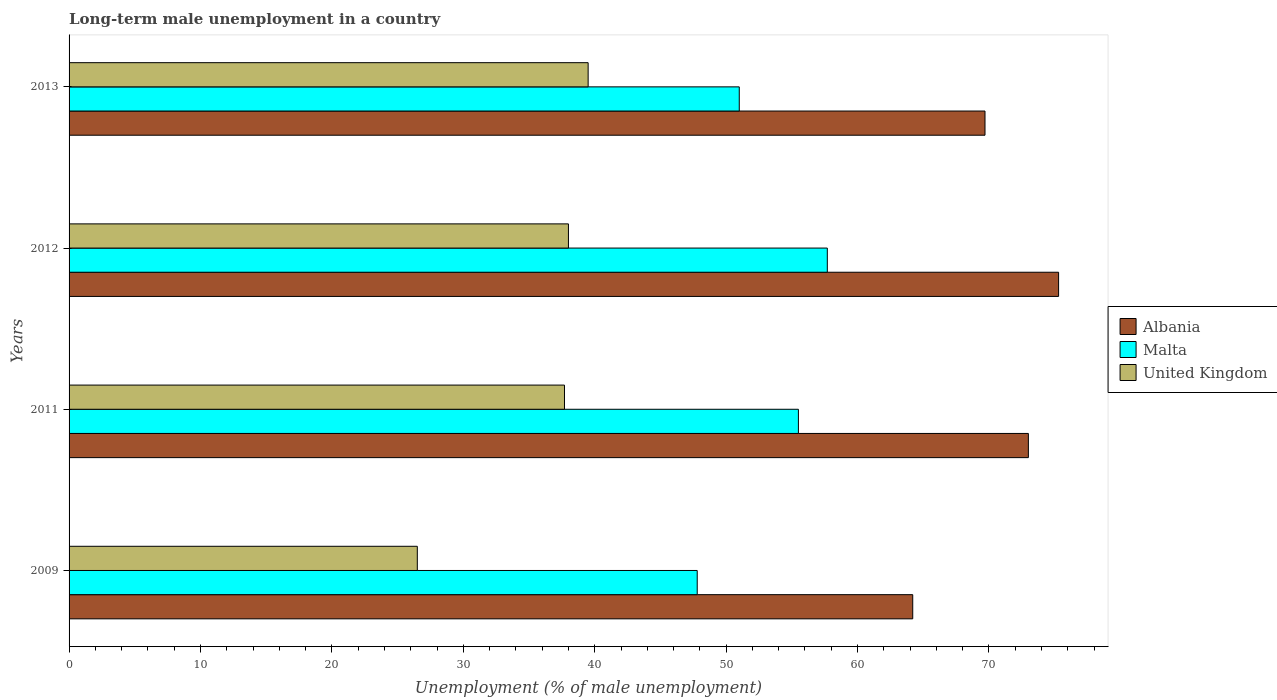How many different coloured bars are there?
Offer a terse response. 3. How many groups of bars are there?
Provide a succinct answer. 4. Are the number of bars per tick equal to the number of legend labels?
Your response must be concise. Yes. How many bars are there on the 4th tick from the top?
Offer a very short reply. 3. What is the label of the 2nd group of bars from the top?
Your answer should be compact. 2012. What is the percentage of long-term unemployed male population in Albania in 2009?
Keep it short and to the point. 64.2. Across all years, what is the maximum percentage of long-term unemployed male population in Albania?
Keep it short and to the point. 75.3. Across all years, what is the minimum percentage of long-term unemployed male population in Malta?
Your answer should be very brief. 47.8. In which year was the percentage of long-term unemployed male population in Malta maximum?
Offer a very short reply. 2012. What is the total percentage of long-term unemployed male population in Albania in the graph?
Your answer should be very brief. 282.2. What is the difference between the percentage of long-term unemployed male population in Malta in 2009 and that in 2013?
Your answer should be very brief. -3.2. What is the difference between the percentage of long-term unemployed male population in Albania in 2009 and the percentage of long-term unemployed male population in United Kingdom in 2013?
Make the answer very short. 24.7. What is the average percentage of long-term unemployed male population in Albania per year?
Make the answer very short. 70.55. In the year 2011, what is the difference between the percentage of long-term unemployed male population in Malta and percentage of long-term unemployed male population in United Kingdom?
Your response must be concise. 17.8. What is the ratio of the percentage of long-term unemployed male population in United Kingdom in 2011 to that in 2013?
Offer a terse response. 0.95. What is the difference between the highest and the second highest percentage of long-term unemployed male population in Albania?
Keep it short and to the point. 2.3. What is the difference between the highest and the lowest percentage of long-term unemployed male population in Malta?
Your response must be concise. 9.9. In how many years, is the percentage of long-term unemployed male population in Albania greater than the average percentage of long-term unemployed male population in Albania taken over all years?
Ensure brevity in your answer.  2. Is the sum of the percentage of long-term unemployed male population in Malta in 2009 and 2013 greater than the maximum percentage of long-term unemployed male population in Albania across all years?
Provide a short and direct response. Yes. What does the 2nd bar from the top in 2013 represents?
Make the answer very short. Malta. What does the 1st bar from the bottom in 2013 represents?
Offer a terse response. Albania. How many bars are there?
Provide a short and direct response. 12. Are all the bars in the graph horizontal?
Your answer should be compact. Yes. How many years are there in the graph?
Keep it short and to the point. 4. What is the difference between two consecutive major ticks on the X-axis?
Ensure brevity in your answer.  10. Does the graph contain grids?
Your response must be concise. No. How are the legend labels stacked?
Make the answer very short. Vertical. What is the title of the graph?
Your answer should be compact. Long-term male unemployment in a country. What is the label or title of the X-axis?
Give a very brief answer. Unemployment (% of male unemployment). What is the Unemployment (% of male unemployment) of Albania in 2009?
Make the answer very short. 64.2. What is the Unemployment (% of male unemployment) of Malta in 2009?
Ensure brevity in your answer.  47.8. What is the Unemployment (% of male unemployment) in Albania in 2011?
Your response must be concise. 73. What is the Unemployment (% of male unemployment) in Malta in 2011?
Offer a very short reply. 55.5. What is the Unemployment (% of male unemployment) in United Kingdom in 2011?
Your answer should be very brief. 37.7. What is the Unemployment (% of male unemployment) of Albania in 2012?
Offer a terse response. 75.3. What is the Unemployment (% of male unemployment) of Malta in 2012?
Keep it short and to the point. 57.7. What is the Unemployment (% of male unemployment) in United Kingdom in 2012?
Give a very brief answer. 38. What is the Unemployment (% of male unemployment) in Albania in 2013?
Provide a short and direct response. 69.7. What is the Unemployment (% of male unemployment) of Malta in 2013?
Make the answer very short. 51. What is the Unemployment (% of male unemployment) of United Kingdom in 2013?
Keep it short and to the point. 39.5. Across all years, what is the maximum Unemployment (% of male unemployment) in Albania?
Your answer should be compact. 75.3. Across all years, what is the maximum Unemployment (% of male unemployment) of Malta?
Offer a terse response. 57.7. Across all years, what is the maximum Unemployment (% of male unemployment) of United Kingdom?
Keep it short and to the point. 39.5. Across all years, what is the minimum Unemployment (% of male unemployment) of Albania?
Give a very brief answer. 64.2. Across all years, what is the minimum Unemployment (% of male unemployment) of Malta?
Make the answer very short. 47.8. Across all years, what is the minimum Unemployment (% of male unemployment) in United Kingdom?
Make the answer very short. 26.5. What is the total Unemployment (% of male unemployment) in Albania in the graph?
Your response must be concise. 282.2. What is the total Unemployment (% of male unemployment) in Malta in the graph?
Provide a short and direct response. 212. What is the total Unemployment (% of male unemployment) in United Kingdom in the graph?
Provide a succinct answer. 141.7. What is the difference between the Unemployment (% of male unemployment) in Albania in 2009 and that in 2011?
Provide a short and direct response. -8.8. What is the difference between the Unemployment (% of male unemployment) in Malta in 2009 and that in 2011?
Offer a very short reply. -7.7. What is the difference between the Unemployment (% of male unemployment) in Albania in 2009 and that in 2012?
Your answer should be compact. -11.1. What is the difference between the Unemployment (% of male unemployment) in Malta in 2009 and that in 2012?
Your response must be concise. -9.9. What is the difference between the Unemployment (% of male unemployment) in United Kingdom in 2009 and that in 2012?
Give a very brief answer. -11.5. What is the difference between the Unemployment (% of male unemployment) in Malta in 2009 and that in 2013?
Your answer should be very brief. -3.2. What is the difference between the Unemployment (% of male unemployment) in United Kingdom in 2009 and that in 2013?
Your response must be concise. -13. What is the difference between the Unemployment (% of male unemployment) of Albania in 2011 and that in 2012?
Provide a short and direct response. -2.3. What is the difference between the Unemployment (% of male unemployment) in Malta in 2011 and that in 2012?
Your answer should be very brief. -2.2. What is the difference between the Unemployment (% of male unemployment) of United Kingdom in 2011 and that in 2013?
Your answer should be very brief. -1.8. What is the difference between the Unemployment (% of male unemployment) of Albania in 2009 and the Unemployment (% of male unemployment) of United Kingdom in 2011?
Give a very brief answer. 26.5. What is the difference between the Unemployment (% of male unemployment) in Albania in 2009 and the Unemployment (% of male unemployment) in Malta in 2012?
Provide a succinct answer. 6.5. What is the difference between the Unemployment (% of male unemployment) in Albania in 2009 and the Unemployment (% of male unemployment) in United Kingdom in 2012?
Offer a very short reply. 26.2. What is the difference between the Unemployment (% of male unemployment) of Albania in 2009 and the Unemployment (% of male unemployment) of United Kingdom in 2013?
Your response must be concise. 24.7. What is the difference between the Unemployment (% of male unemployment) in Albania in 2011 and the Unemployment (% of male unemployment) in United Kingdom in 2013?
Offer a very short reply. 33.5. What is the difference between the Unemployment (% of male unemployment) in Malta in 2011 and the Unemployment (% of male unemployment) in United Kingdom in 2013?
Give a very brief answer. 16. What is the difference between the Unemployment (% of male unemployment) in Albania in 2012 and the Unemployment (% of male unemployment) in Malta in 2013?
Your answer should be very brief. 24.3. What is the difference between the Unemployment (% of male unemployment) in Albania in 2012 and the Unemployment (% of male unemployment) in United Kingdom in 2013?
Your answer should be compact. 35.8. What is the difference between the Unemployment (% of male unemployment) in Malta in 2012 and the Unemployment (% of male unemployment) in United Kingdom in 2013?
Your response must be concise. 18.2. What is the average Unemployment (% of male unemployment) in Albania per year?
Offer a very short reply. 70.55. What is the average Unemployment (% of male unemployment) in Malta per year?
Your answer should be very brief. 53. What is the average Unemployment (% of male unemployment) of United Kingdom per year?
Keep it short and to the point. 35.42. In the year 2009, what is the difference between the Unemployment (% of male unemployment) of Albania and Unemployment (% of male unemployment) of Malta?
Ensure brevity in your answer.  16.4. In the year 2009, what is the difference between the Unemployment (% of male unemployment) in Albania and Unemployment (% of male unemployment) in United Kingdom?
Provide a short and direct response. 37.7. In the year 2009, what is the difference between the Unemployment (% of male unemployment) in Malta and Unemployment (% of male unemployment) in United Kingdom?
Offer a very short reply. 21.3. In the year 2011, what is the difference between the Unemployment (% of male unemployment) in Albania and Unemployment (% of male unemployment) in United Kingdom?
Provide a short and direct response. 35.3. In the year 2011, what is the difference between the Unemployment (% of male unemployment) of Malta and Unemployment (% of male unemployment) of United Kingdom?
Your answer should be compact. 17.8. In the year 2012, what is the difference between the Unemployment (% of male unemployment) of Albania and Unemployment (% of male unemployment) of Malta?
Your answer should be very brief. 17.6. In the year 2012, what is the difference between the Unemployment (% of male unemployment) in Albania and Unemployment (% of male unemployment) in United Kingdom?
Offer a terse response. 37.3. In the year 2013, what is the difference between the Unemployment (% of male unemployment) of Albania and Unemployment (% of male unemployment) of Malta?
Your answer should be very brief. 18.7. In the year 2013, what is the difference between the Unemployment (% of male unemployment) of Albania and Unemployment (% of male unemployment) of United Kingdom?
Offer a terse response. 30.2. In the year 2013, what is the difference between the Unemployment (% of male unemployment) in Malta and Unemployment (% of male unemployment) in United Kingdom?
Give a very brief answer. 11.5. What is the ratio of the Unemployment (% of male unemployment) of Albania in 2009 to that in 2011?
Keep it short and to the point. 0.88. What is the ratio of the Unemployment (% of male unemployment) of Malta in 2009 to that in 2011?
Offer a terse response. 0.86. What is the ratio of the Unemployment (% of male unemployment) in United Kingdom in 2009 to that in 2011?
Ensure brevity in your answer.  0.7. What is the ratio of the Unemployment (% of male unemployment) of Albania in 2009 to that in 2012?
Provide a succinct answer. 0.85. What is the ratio of the Unemployment (% of male unemployment) of Malta in 2009 to that in 2012?
Offer a terse response. 0.83. What is the ratio of the Unemployment (% of male unemployment) in United Kingdom in 2009 to that in 2012?
Provide a succinct answer. 0.7. What is the ratio of the Unemployment (% of male unemployment) of Albania in 2009 to that in 2013?
Offer a very short reply. 0.92. What is the ratio of the Unemployment (% of male unemployment) in Malta in 2009 to that in 2013?
Your response must be concise. 0.94. What is the ratio of the Unemployment (% of male unemployment) of United Kingdom in 2009 to that in 2013?
Offer a terse response. 0.67. What is the ratio of the Unemployment (% of male unemployment) of Albania in 2011 to that in 2012?
Give a very brief answer. 0.97. What is the ratio of the Unemployment (% of male unemployment) in Malta in 2011 to that in 2012?
Provide a short and direct response. 0.96. What is the ratio of the Unemployment (% of male unemployment) in United Kingdom in 2011 to that in 2012?
Your response must be concise. 0.99. What is the ratio of the Unemployment (% of male unemployment) in Albania in 2011 to that in 2013?
Ensure brevity in your answer.  1.05. What is the ratio of the Unemployment (% of male unemployment) in Malta in 2011 to that in 2013?
Provide a short and direct response. 1.09. What is the ratio of the Unemployment (% of male unemployment) in United Kingdom in 2011 to that in 2013?
Your answer should be very brief. 0.95. What is the ratio of the Unemployment (% of male unemployment) in Albania in 2012 to that in 2013?
Provide a succinct answer. 1.08. What is the ratio of the Unemployment (% of male unemployment) in Malta in 2012 to that in 2013?
Your answer should be compact. 1.13. What is the ratio of the Unemployment (% of male unemployment) in United Kingdom in 2012 to that in 2013?
Provide a succinct answer. 0.96. What is the difference between the highest and the second highest Unemployment (% of male unemployment) in Malta?
Give a very brief answer. 2.2. What is the difference between the highest and the lowest Unemployment (% of male unemployment) of Albania?
Provide a succinct answer. 11.1. 